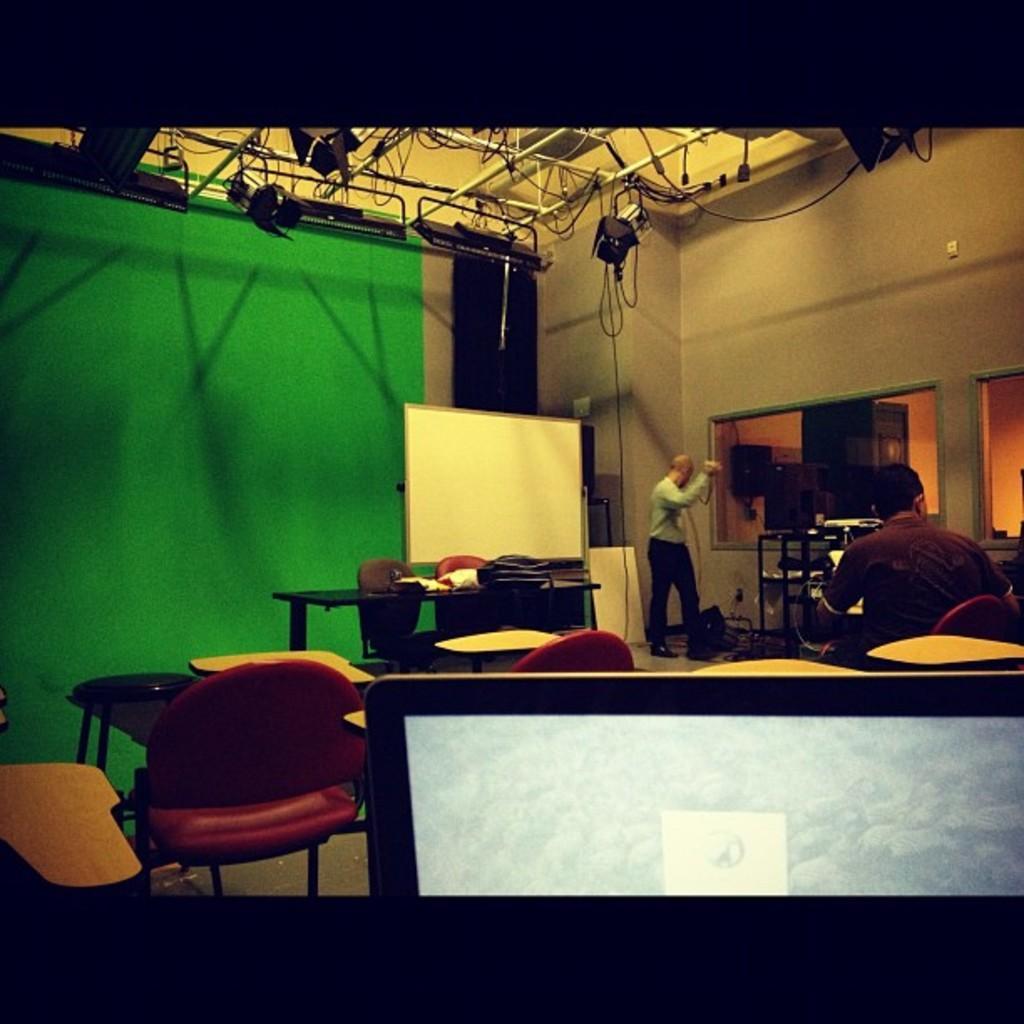Could you give a brief overview of what you see in this image? Here in this picture there are two men. One men is standing and the other man is sitting in the red chair. There is a green color wall. There is a whiteboard. On the table there is a bag. And to the right corner we can see a screen. On the top there are some lighting. 